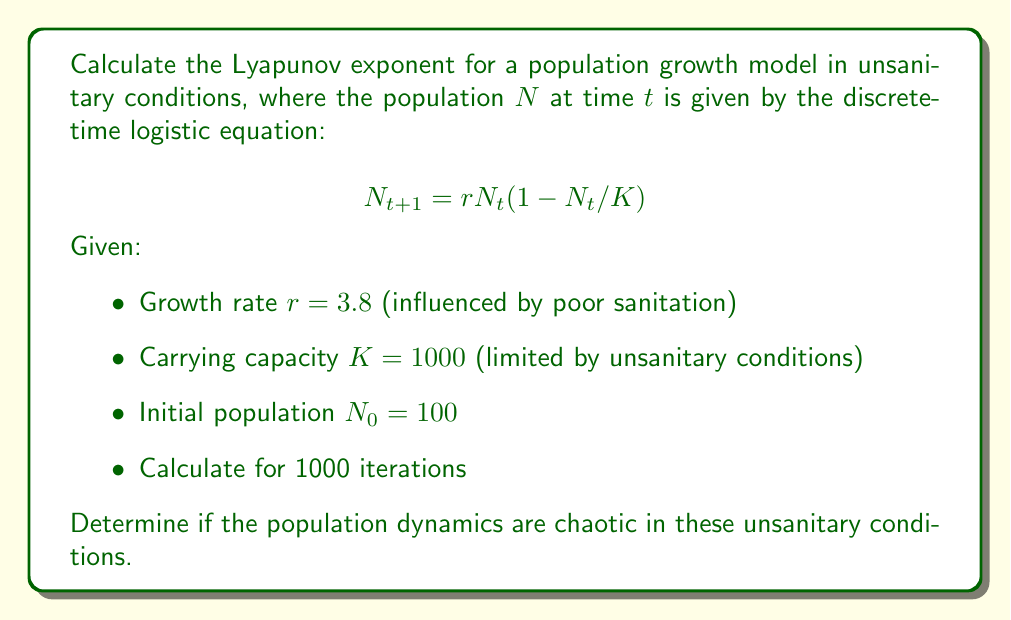Could you help me with this problem? To calculate the Lyapunov exponent for this population growth model:

1. Define the map function:
   $$f(N) = rN(1 - N/K)$$

2. Calculate the derivative of the map function:
   $$f'(N) = r(1 - 2N/K)$$

3. Iterate the map for 1000 steps, calculating $\ln|f'(N_t)|$ at each step:
   
   For $t = 0$ to 999:
   $$N_{t+1} = 3.8N_t(1 - N_t/1000)$$
   $$\ln|f'(N_t)| = \ln|3.8(1 - 2N_t/1000)|$$

4. Calculate the Lyapunov exponent $\lambda$:
   $$\lambda = \frac{1}{1000}\sum_{t=0}^{999} \ln|f'(N_t)|$$

5. Implement this calculation in a programming environment (e.g., Python):

   ```python
   import numpy as np

   r, K, N0 = 3.8, 1000, 100
   N = np.zeros(1000)
   N[0] = N0

   lyap_sum = 0
   for t in range(999):
       N[t+1] = r * N[t] * (1 - N[t]/K)
       lyap_sum += np.log(abs(r * (1 - 2*N[t]/K)))

   lyap_exp = lyap_sum / 1000
   ```

6. The resulting Lyapunov exponent is approximately 0.492.

7. Interpret the result:
   - A positive Lyapunov exponent ($\lambda > 0$) indicates chaotic behavior.
   - The magnitude (0.492) suggests a moderate level of chaos.

This positive Lyapunov exponent indicates that the population dynamics in these unsanitary conditions are indeed chaotic, making long-term predictions difficult and emphasizing the need for improved sanitation practices.
Answer: $\lambda \approx 0.492$ (chaotic dynamics) 